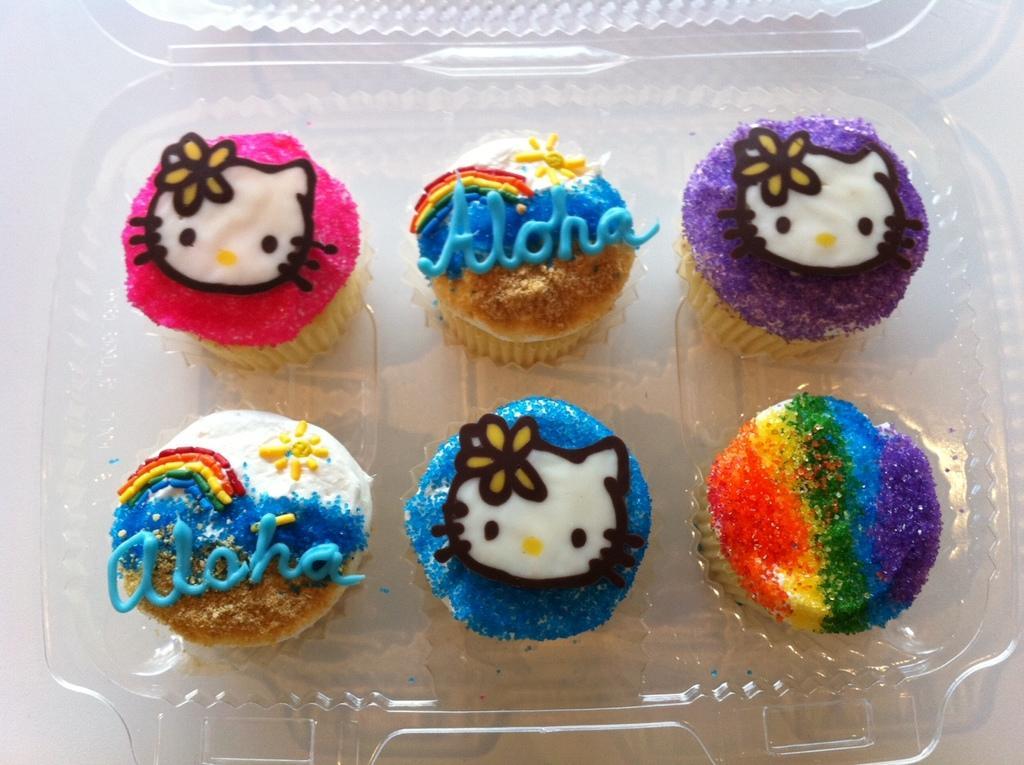Please provide a concise description of this image. In this image we can see cupcakes in packet placed on the table. 